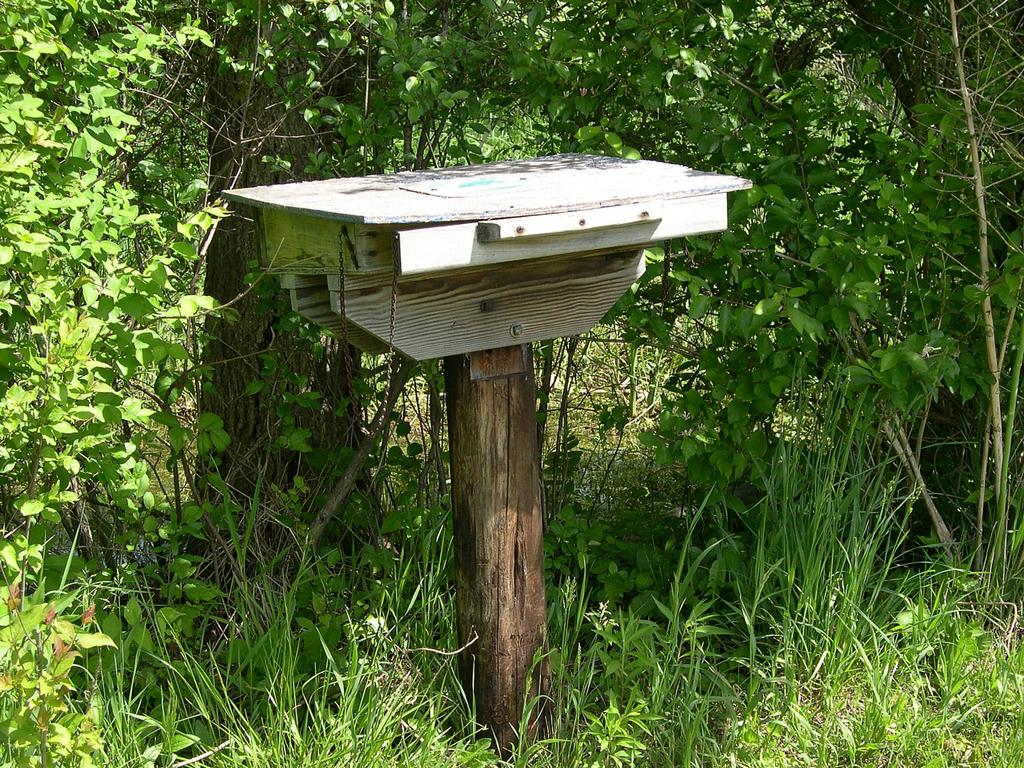What type of vegetation can be seen in the image? There are trees and grass in the image. What is the color of the object on the wooden pole? The object on the wooden pole is white. What type of fruit is hanging from the trees in the image? There is no fruit visible in the image; only trees and grass are present. Can you see an owl perched on one of the branches in the image? There is no owl present in the image. 